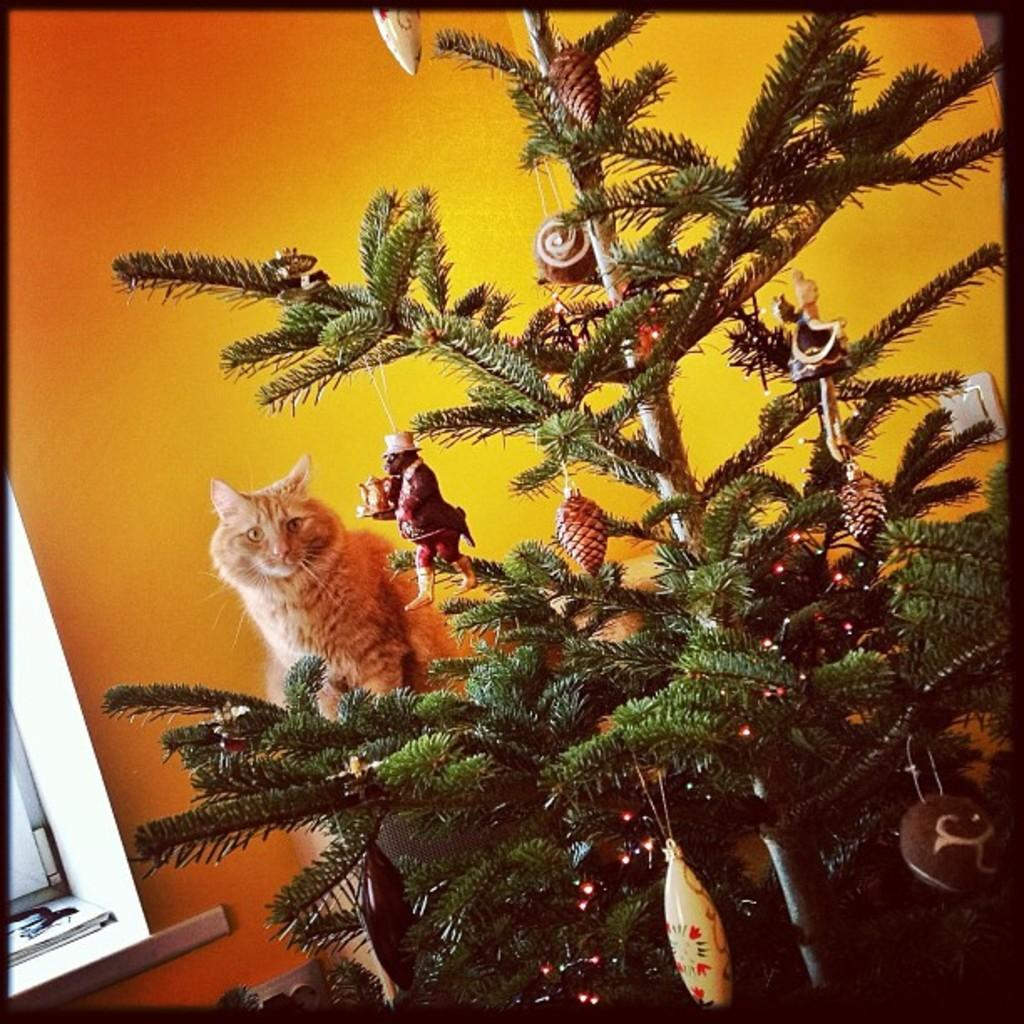What is the main subject of the image? There is a Christmas tree in the image. Where is the Christmas tree located? The Christmas tree is in front of a wall. What other object or animal can be seen in the image? There is a cat in the middle of the image. What type of ornament is the daughter holding in the image? There is no daughter present in the image, and therefore no ornament can be held by her. 